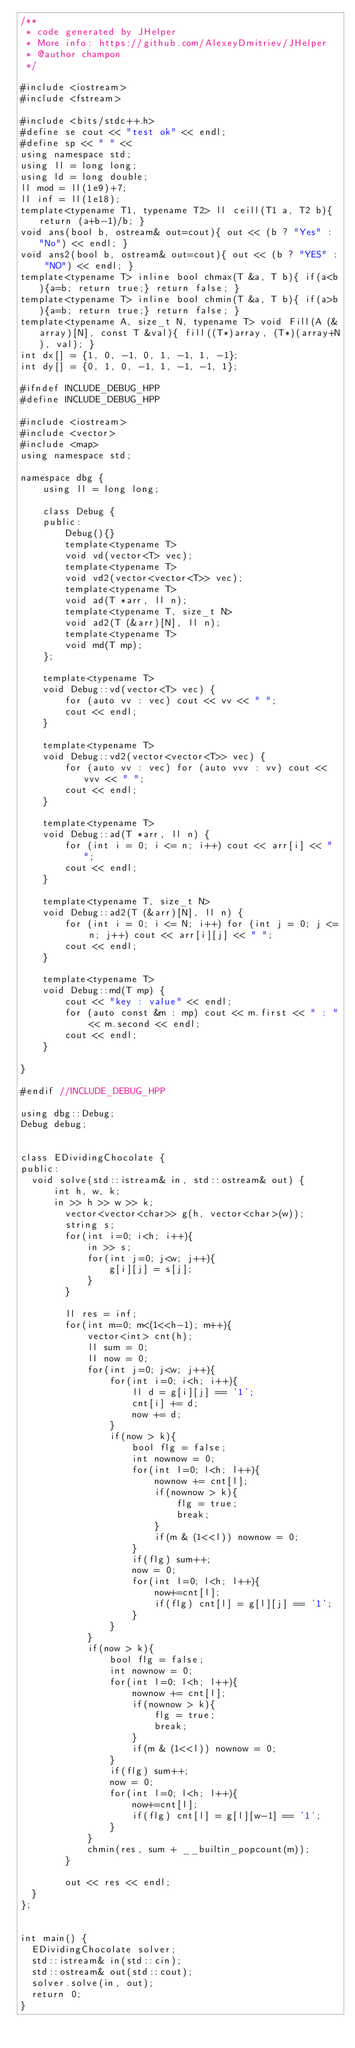Convert code to text. <code><loc_0><loc_0><loc_500><loc_500><_C++_>/**
 * code generated by JHelper
 * More info: https://github.com/AlexeyDmitriev/JHelper
 * @author champon
 */

#include <iostream>
#include <fstream>

#include <bits/stdc++.h>
#define se cout << "test ok" << endl;
#define sp << " " <<
using namespace std;
using ll = long long;
using ld = long double;
ll mod = ll(1e9)+7;
ll inf = ll(1e18);
template<typename T1, typename T2> ll ceill(T1 a, T2 b){ return (a+b-1)/b; }
void ans(bool b, ostream& out=cout){ out << (b ? "Yes" : "No") << endl; }
void ans2(bool b, ostream& out=cout){ out << (b ? "YES" : "NO") << endl; }
template<typename T> inline bool chmax(T &a, T b){ if(a<b){a=b; return true;} return false; }
template<typename T> inline bool chmin(T &a, T b){ if(a>b){a=b; return true;} return false; }
template<typename A, size_t N, typename T> void Fill(A (&array)[N], const T &val){ fill((T*)array, (T*)(array+N), val); }
int dx[] = {1, 0, -1, 0, 1, -1, 1, -1};
int dy[] = {0, 1, 0, -1, 1, -1, -1, 1};

#ifndef INCLUDE_DEBUG_HPP
#define INCLUDE_DEBUG_HPP

#include <iostream>
#include <vector>
#include <map>
using namespace std;

namespace dbg {
    using ll = long long;

    class Debug {
    public:
        Debug(){}
        template<typename T>
        void vd(vector<T> vec);
        template<typename T>
        void vd2(vector<vector<T>> vec);
        template<typename T>
        void ad(T *arr, ll n);
        template<typename T, size_t N>
        void ad2(T (&arr)[N], ll n);
        template<typename T>
        void md(T mp);
    };

    template<typename T>
    void Debug::vd(vector<T> vec) {
        for (auto vv : vec) cout << vv << " ";
        cout << endl;
    }

    template<typename T>
    void Debug::vd2(vector<vector<T>> vec) {
        for (auto vv : vec) for (auto vvv : vv) cout << vvv << " ";
        cout << endl;
    }

    template<typename T>
    void Debug::ad(T *arr, ll n) {
        for (int i = 0; i <= n; i++) cout << arr[i] << " ";
        cout << endl;
    }

    template<typename T, size_t N>
    void Debug::ad2(T (&arr)[N], ll n) {
        for (int i = 0; i <= N; i++) for (int j = 0; j <= n; j++) cout << arr[i][j] << " ";
        cout << endl;
    }

    template<typename T>
    void Debug::md(T mp) {
        cout << "key : value" << endl;
        for (auto const &m : mp) cout << m.first << " : " << m.second << endl;
        cout << endl;
    }

}

#endif //INCLUDE_DEBUG_HPP

using dbg::Debug;
Debug debug;


class EDividingChocolate {
public:
	void solve(std::istream& in, std::ostream& out) {
	    int h, w, k;
	    in >> h >> w >> k;
        vector<vector<char>> g(h, vector<char>(w));
        string s;
        for(int i=0; i<h; i++){
            in >> s;
            for(int j=0; j<w; j++){
                g[i][j] = s[j];
            }
        }

        ll res = inf;
        for(int m=0; m<(1<<h-1); m++){
            vector<int> cnt(h);
            ll sum = 0;
            ll now = 0;
            for(int j=0; j<w; j++){
                for(int i=0; i<h; i++){
                    ll d = g[i][j] == '1';
                    cnt[i] += d;
                    now += d;
                }
                if(now > k){
                    bool flg = false;
                    int nownow = 0;
                    for(int l=0; l<h; l++){
                        nownow += cnt[l];
                        if(nownow > k){
                            flg = true;
                            break;
                        }
                        if(m & (1<<l)) nownow = 0;
                    }
                    if(flg) sum++;
                    now = 0;
                    for(int l=0; l<h; l++){
                        now+=cnt[l];
                        if(flg) cnt[l] = g[l][j] == '1';
                    }
                }
            }
            if(now > k){
                bool flg = false;
                int nownow = 0;
                for(int l=0; l<h; l++){
                    nownow += cnt[l];
                    if(nownow > k){
                        flg = true;
                        break;
                    }
                    if(m & (1<<l)) nownow = 0;
                }
                if(flg) sum++;
                now = 0;
                for(int l=0; l<h; l++){
                    now+=cnt[l];
                    if(flg) cnt[l] = g[l][w-1] == '1';
                }
            }
            chmin(res, sum + __builtin_popcount(m));
        }

        out << res << endl;
	}
};


int main() {
	EDividingChocolate solver;
	std::istream& in(std::cin);
	std::ostream& out(std::cout);
	solver.solve(in, out);
	return 0;
}
</code> 